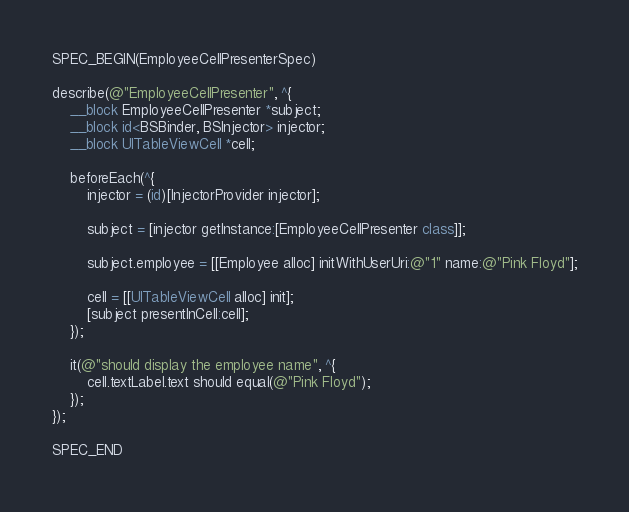Convert code to text. <code><loc_0><loc_0><loc_500><loc_500><_ObjectiveC_>
SPEC_BEGIN(EmployeeCellPresenterSpec)

describe(@"EmployeeCellPresenter", ^{
    __block EmployeeCellPresenter *subject;
    __block id<BSBinder, BSInjector> injector;
    __block UITableViewCell *cell;

    beforeEach(^{
        injector = (id)[InjectorProvider injector];

        subject = [injector getInstance:[EmployeeCellPresenter class]];
        
        subject.employee = [[Employee alloc] initWithUserUri:@"1" name:@"Pink Floyd"];
        
        cell = [[UITableViewCell alloc] init];
        [subject presentInCell:cell];
    });
    
    it(@"should display the employee name", ^{
        cell.textLabel.text should equal(@"Pink Floyd");
    });
});

SPEC_END
</code> 